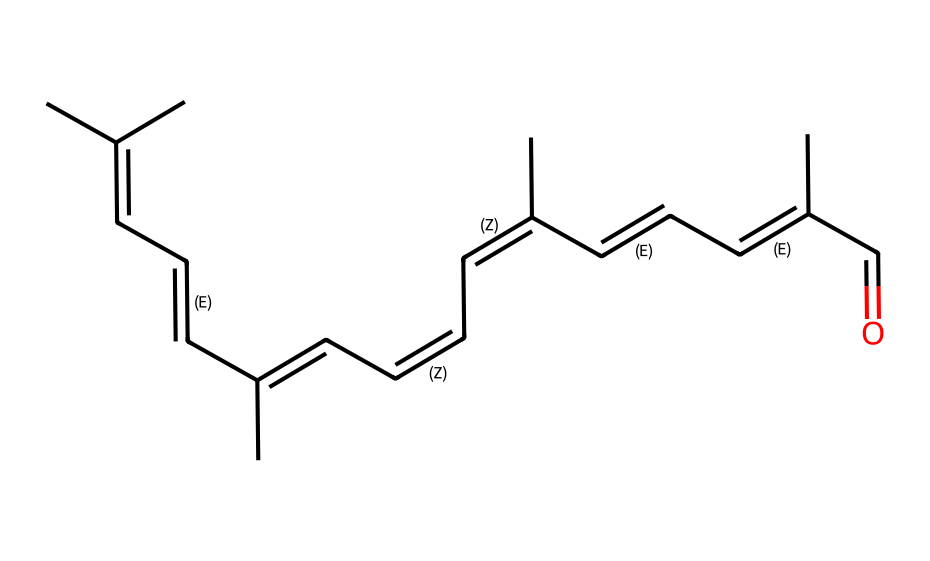What is the main functional group present in cis-retinal? The presence of the C=O double bond indicates the presence of a carbonyl functional group, characteristic of aldehydes.
Answer: carbonyl How many double bonds are present in the structure of cis-retinal? By examining the SMILES representation, we can count a total of 8 double bonds depicted in the consecutive C=C pairs.
Answer: 8 What is the longest carbon chain in cis-retinal? The longest continuous chain with carbon atoms comprises 15 carbons, as traced through the linear connections in the structure.
Answer: 15 Which geometric isomer corresponds to the cis configuration? The arrangement of substituents on the double bonds shows that cis-retinal has substituents on the same side of the carbon chain at two double bond positions.
Answer: cis What type of isomerism does cis-retinal exhibit? Based on the presence of multiple double bonds and variations in spatial arrangement, cis-retinal showcases geometric (cis-trans) isomerism.
Answer: geometric 